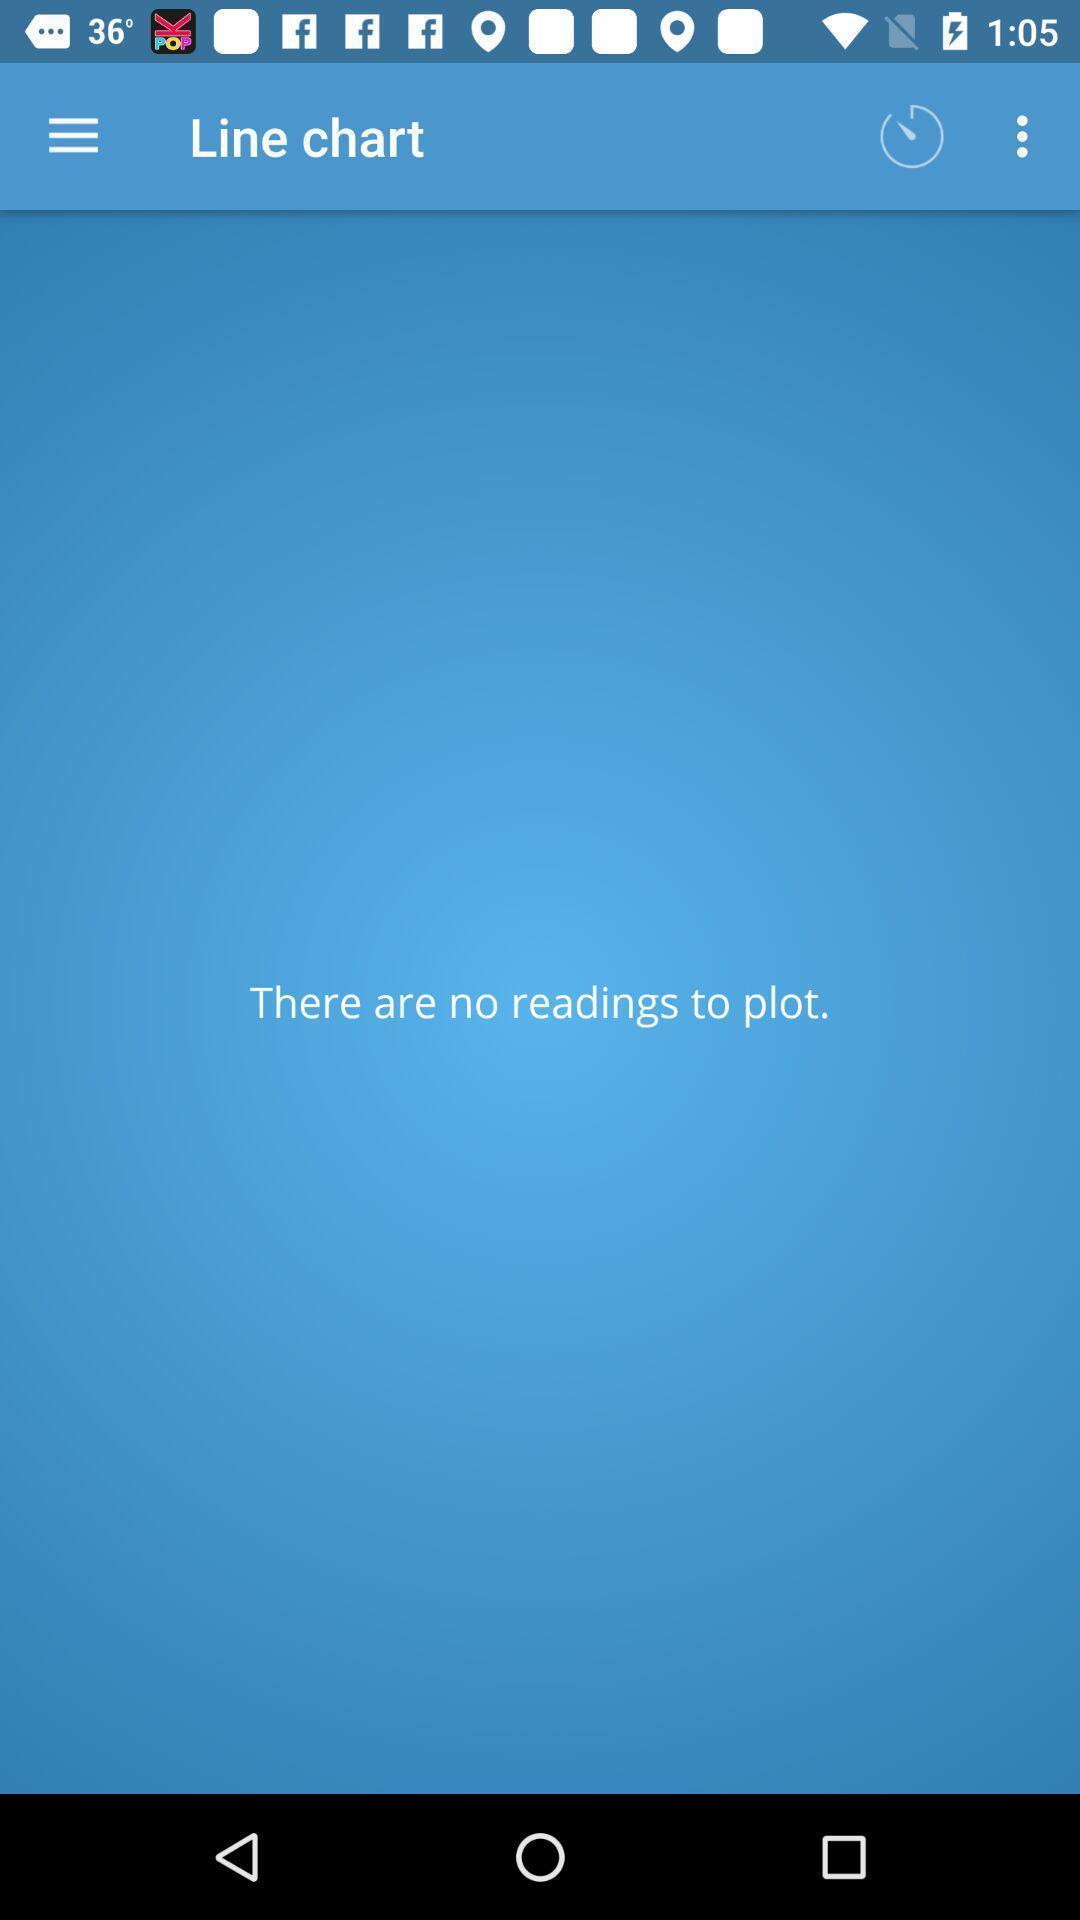Explain the elements present in this screenshot. Page showing blank page in line chart. 